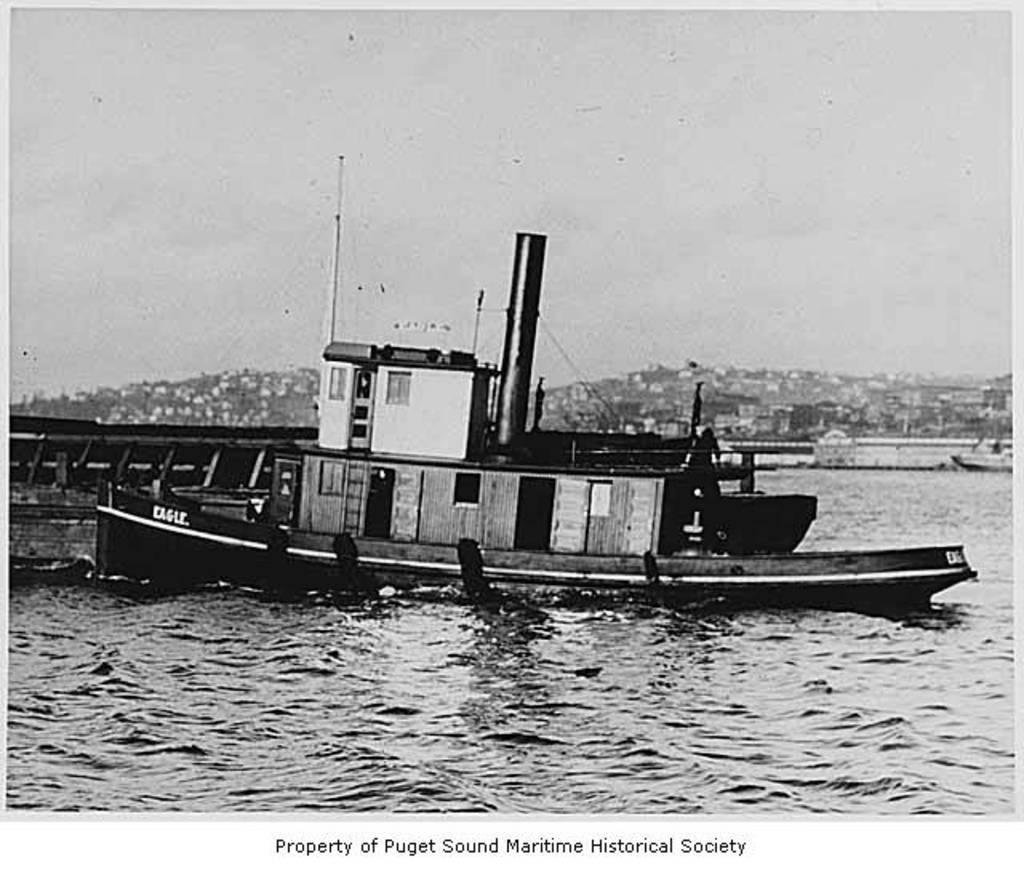In one or two sentences, can you explain what this image depicts? This is a black and white picture. In the foreground of the pictures there is a water body, in the water there are ships. In the background there are buildings. At the bottom there is text. 